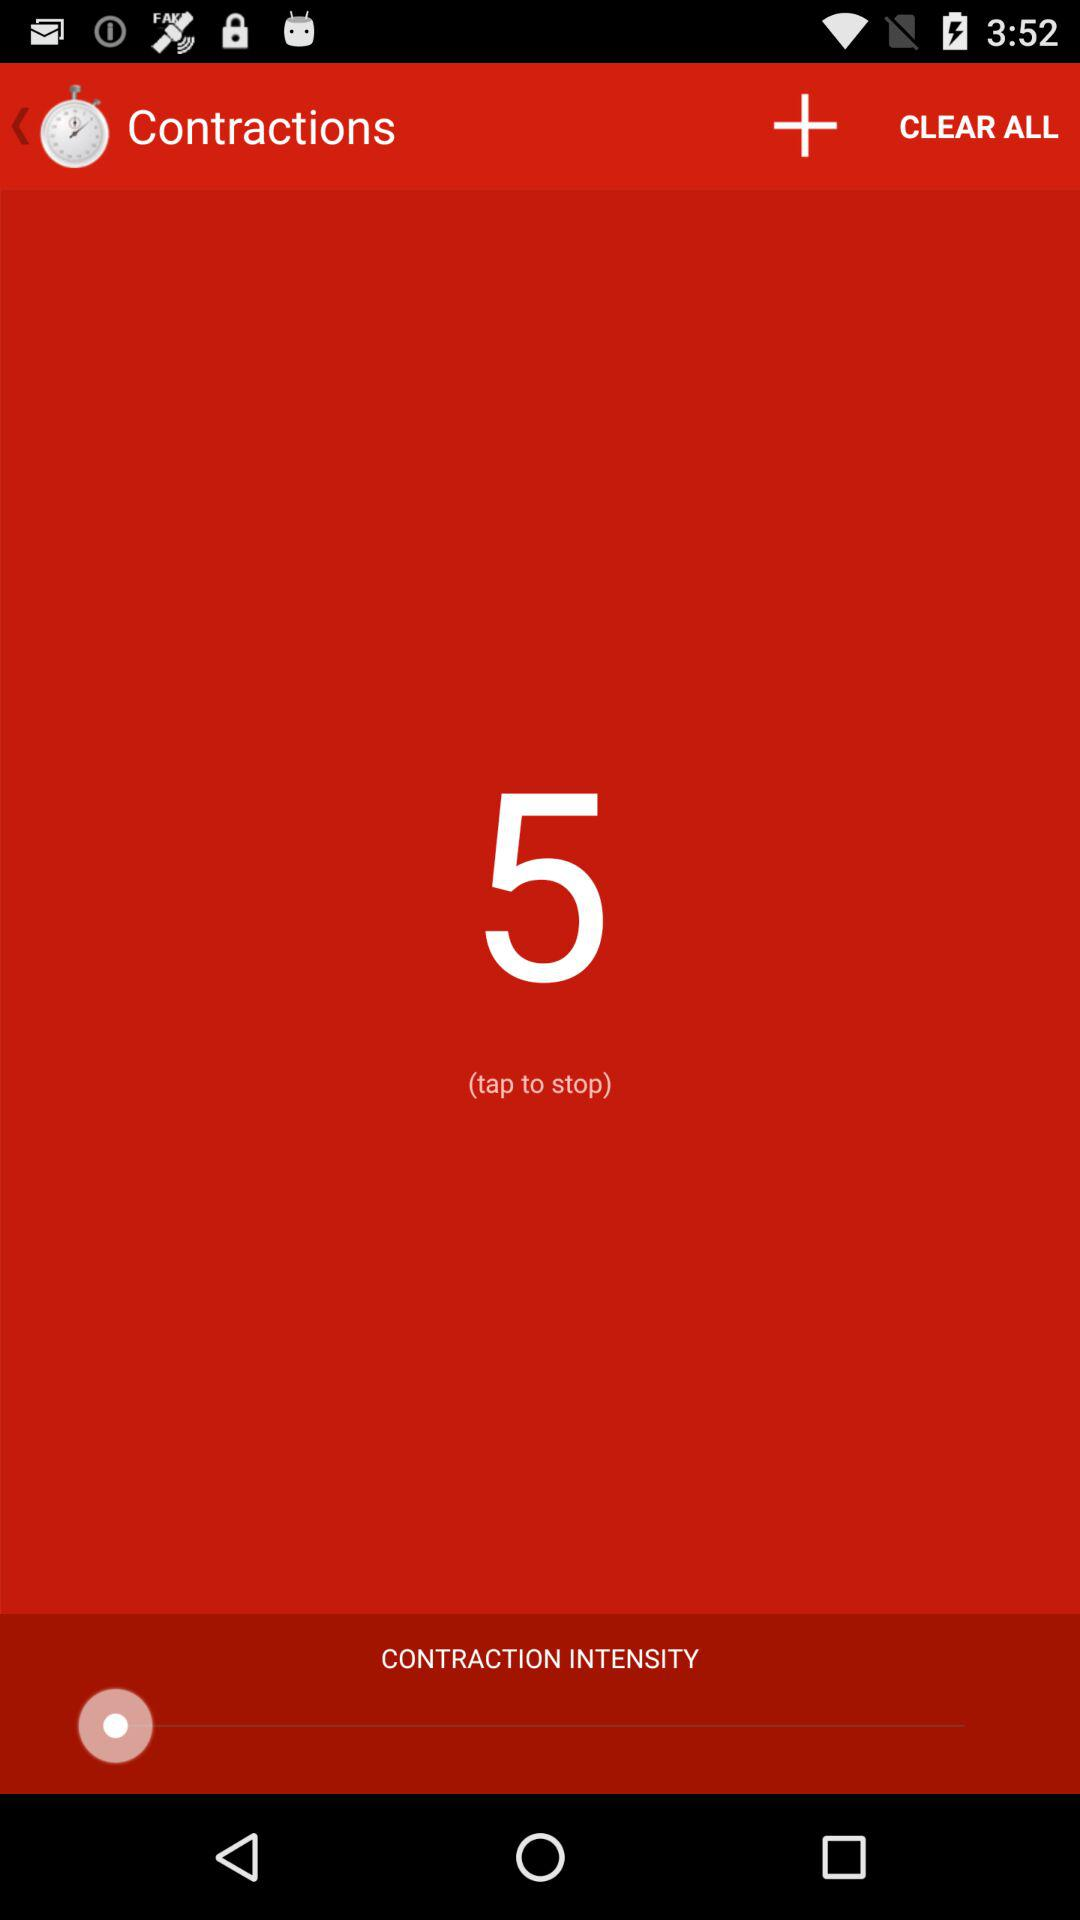How many more contractions have been recorded than cleared?
Answer the question using a single word or phrase. 5 